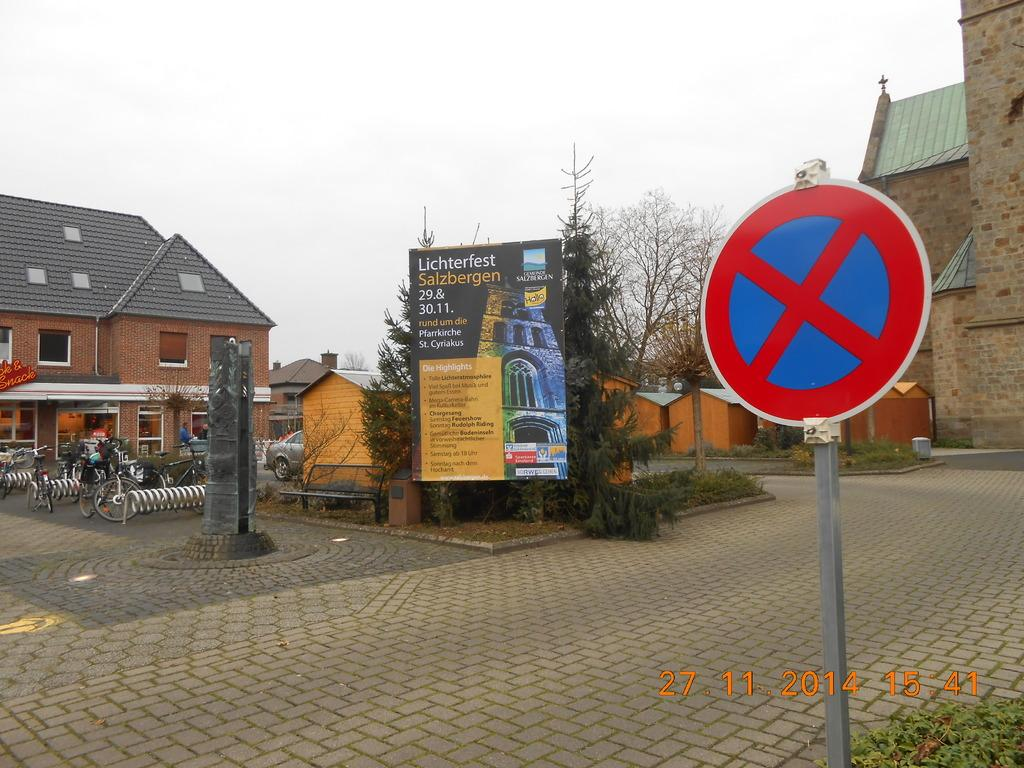Provide a one-sentence caption for the provided image. A sign advertises Lichterfest Salzbergen amidst a town square. 